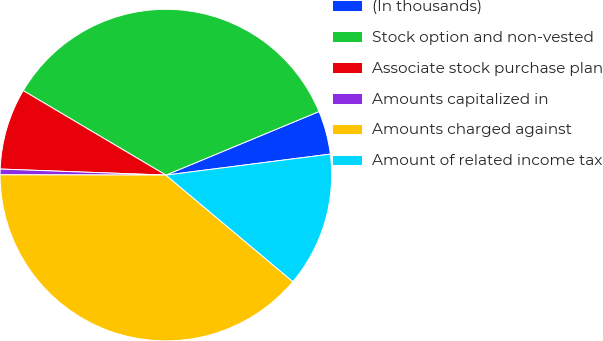Convert chart to OTSL. <chart><loc_0><loc_0><loc_500><loc_500><pie_chart><fcel>(In thousands)<fcel>Stock option and non-vested<fcel>Associate stock purchase plan<fcel>Amounts capitalized in<fcel>Amounts charged against<fcel>Amount of related income tax<nl><fcel>4.24%<fcel>35.23%<fcel>7.93%<fcel>0.55%<fcel>38.92%<fcel>13.13%<nl></chart> 